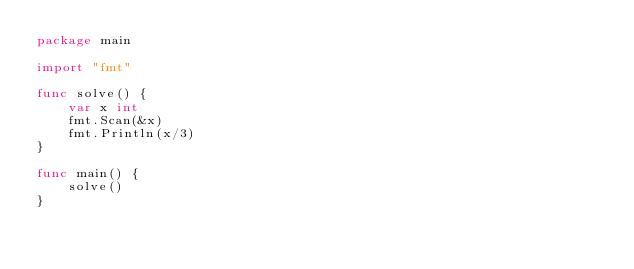Convert code to text. <code><loc_0><loc_0><loc_500><loc_500><_Go_>package main

import "fmt"

func solve() {
	var x int
	fmt.Scan(&x)
	fmt.Println(x/3)
}

func main() {
	solve()
}
</code> 